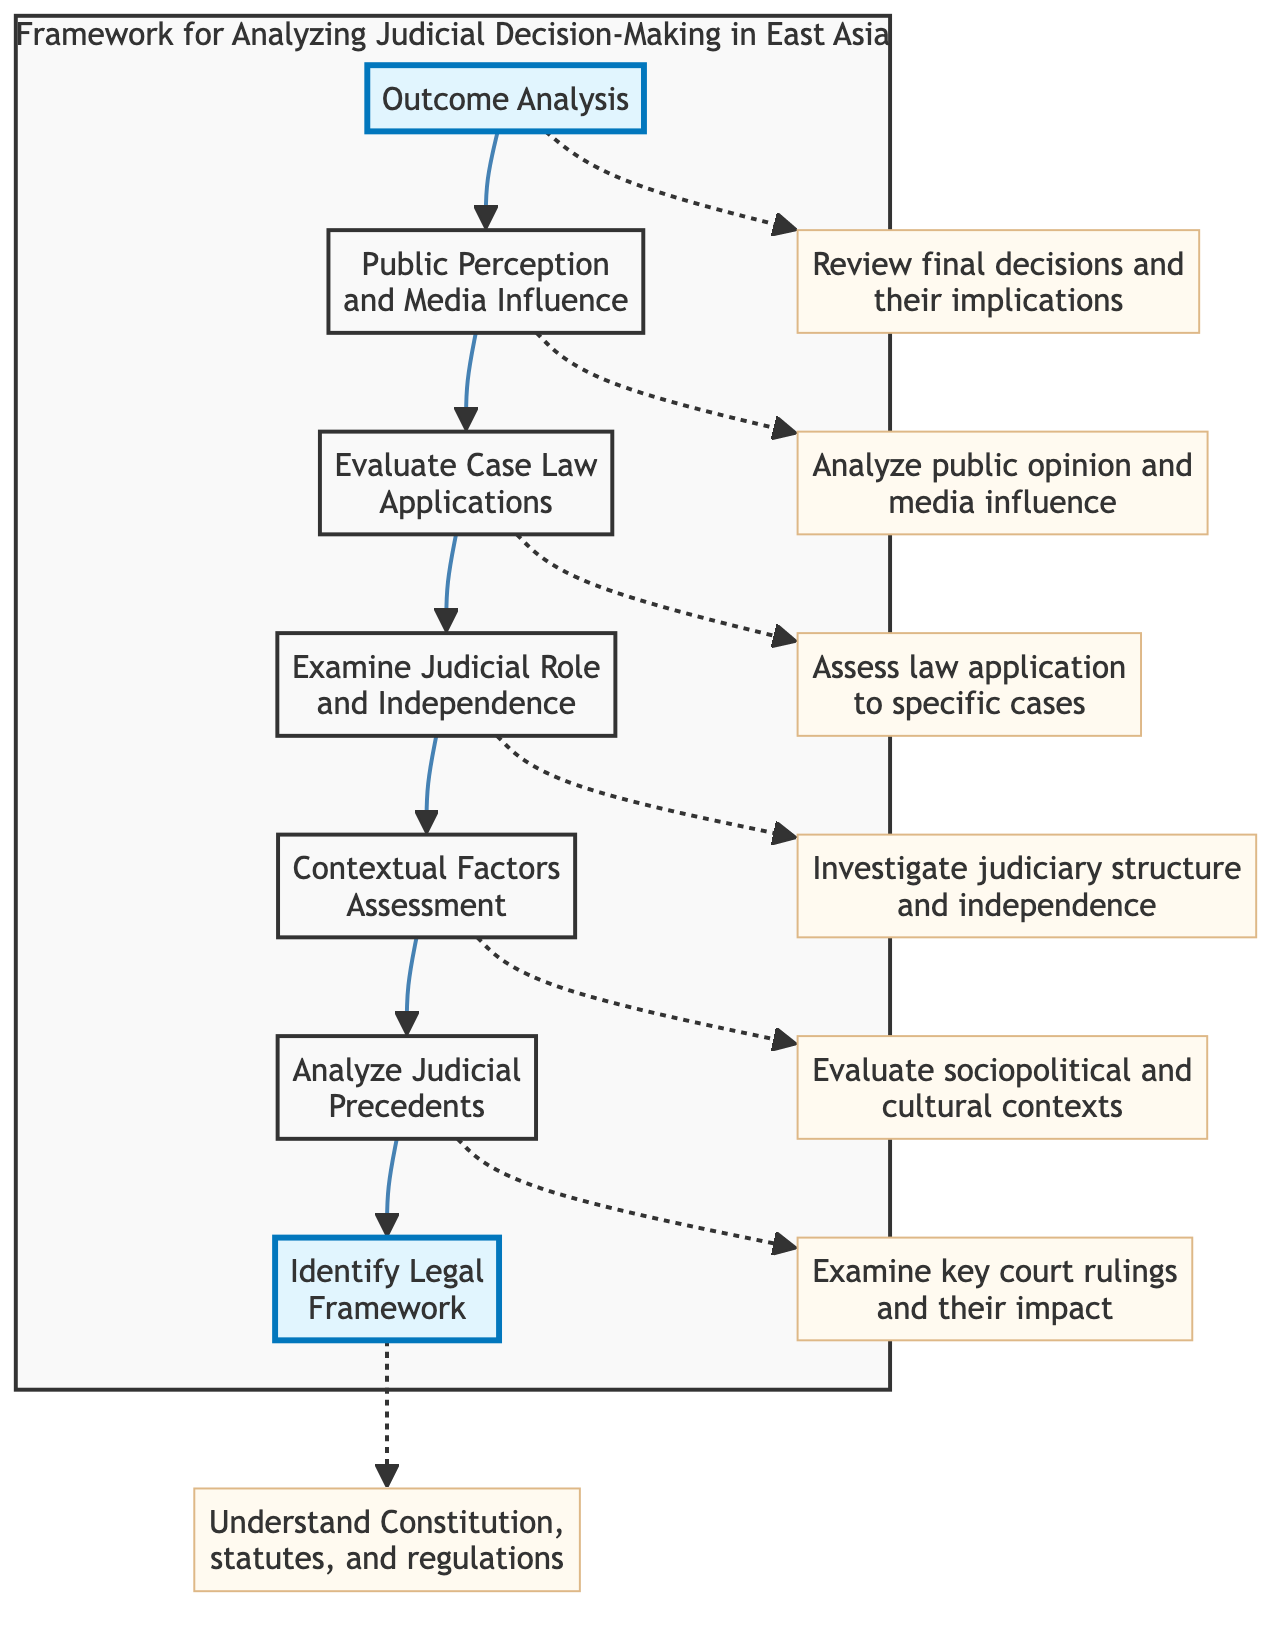What is the first step in the framework? The first step in the framework, as indicated by the diagram, is "Outcome Analysis," which is at the top of the flow.
Answer: Outcome Analysis How many nodes are in the diagram? The diagram consists of seven distinct nodes representing different steps in the judicial decision-making analysis.
Answer: 7 What does the node "Examine Judicial Role and Independence" precede? The diagram shows that the node "Examine Judicial Role and Independence" comes before the node "Contextual Factors Assessment," establishing a direct flow from one to the other.
Answer: Contextual Factors Assessment What is analyzed after "Public Perception and Media Influence"? According to the diagram, "Evaluate Case Law Applications" follows "Public Perception and Media Influence," indicating the next step in the process.
Answer: Evaluate Case Law Applications Which node leads to "Identify Legal Framework"? The node directly leading to "Identify Legal Framework" is "Analyze Judicial Precedents," creating a sequential relationship between the two steps.
Answer: Analyze Judicial Precedents How many steps follow "Evaluate Case Law Applications"? There are two subsequent steps following "Evaluate Case Law Applications": "Examine Judicial Role and Independence" and "Contextual Factors Assessment."
Answer: 2 What is the last node in the diagram? The last node in the flowchart that signifies the conclusion of the analysis is "Identify Legal Framework," placed at the bottom of the diagram.
Answer: Identify Legal Framework What influences are considered before "Outcome Analysis"? Before reaching "Outcome Analysis," the influences considered include "Public Perception and Media Influence." This shows the order of evaluation leading to the final outcome.
Answer: Public Perception and Media Influence What type of factors are assessed in "Contextual Factors Assessment"? The types of factors assessed in "Contextual Factors Assessment" include sociopolitical and cultural contexts, which are crucial for understanding judicial reasoning.
Answer: Sociopolitical and cultural contexts 